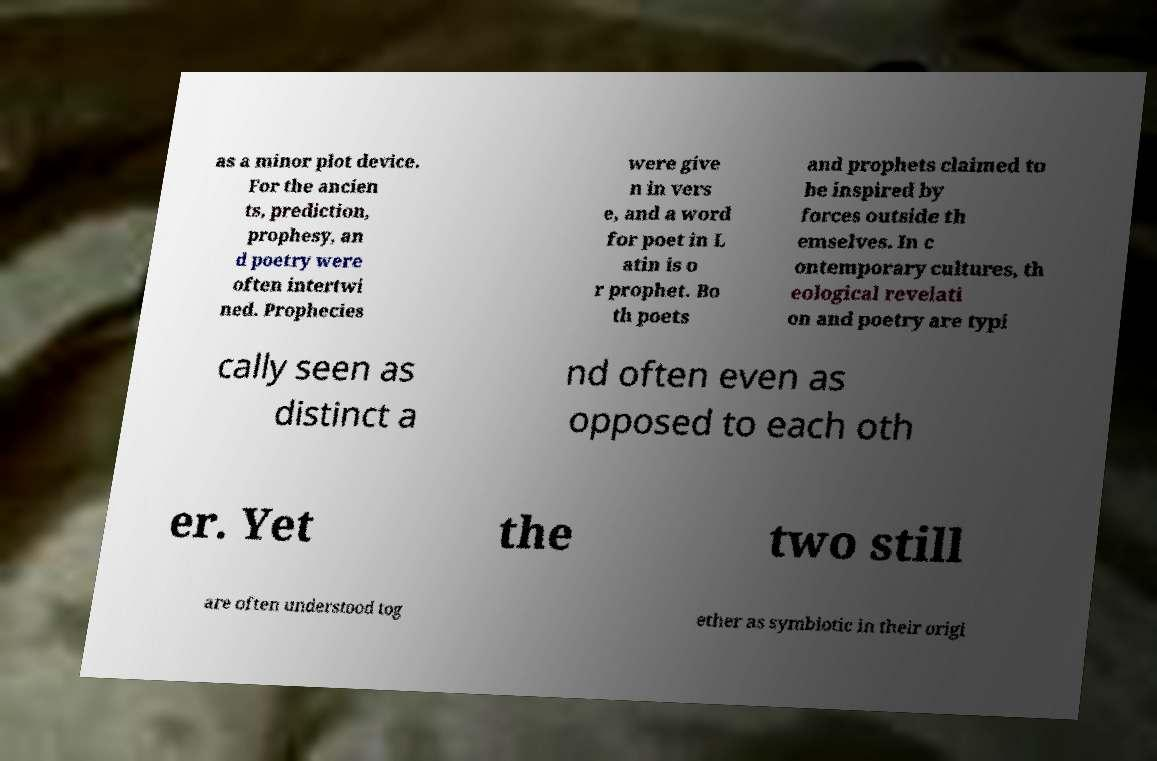What messages or text are displayed in this image? I need them in a readable, typed format. as a minor plot device. For the ancien ts, prediction, prophesy, an d poetry were often intertwi ned. Prophecies were give n in vers e, and a word for poet in L atin is o r prophet. Bo th poets and prophets claimed to be inspired by forces outside th emselves. In c ontemporary cultures, th eological revelati on and poetry are typi cally seen as distinct a nd often even as opposed to each oth er. Yet the two still are often understood tog ether as symbiotic in their origi 